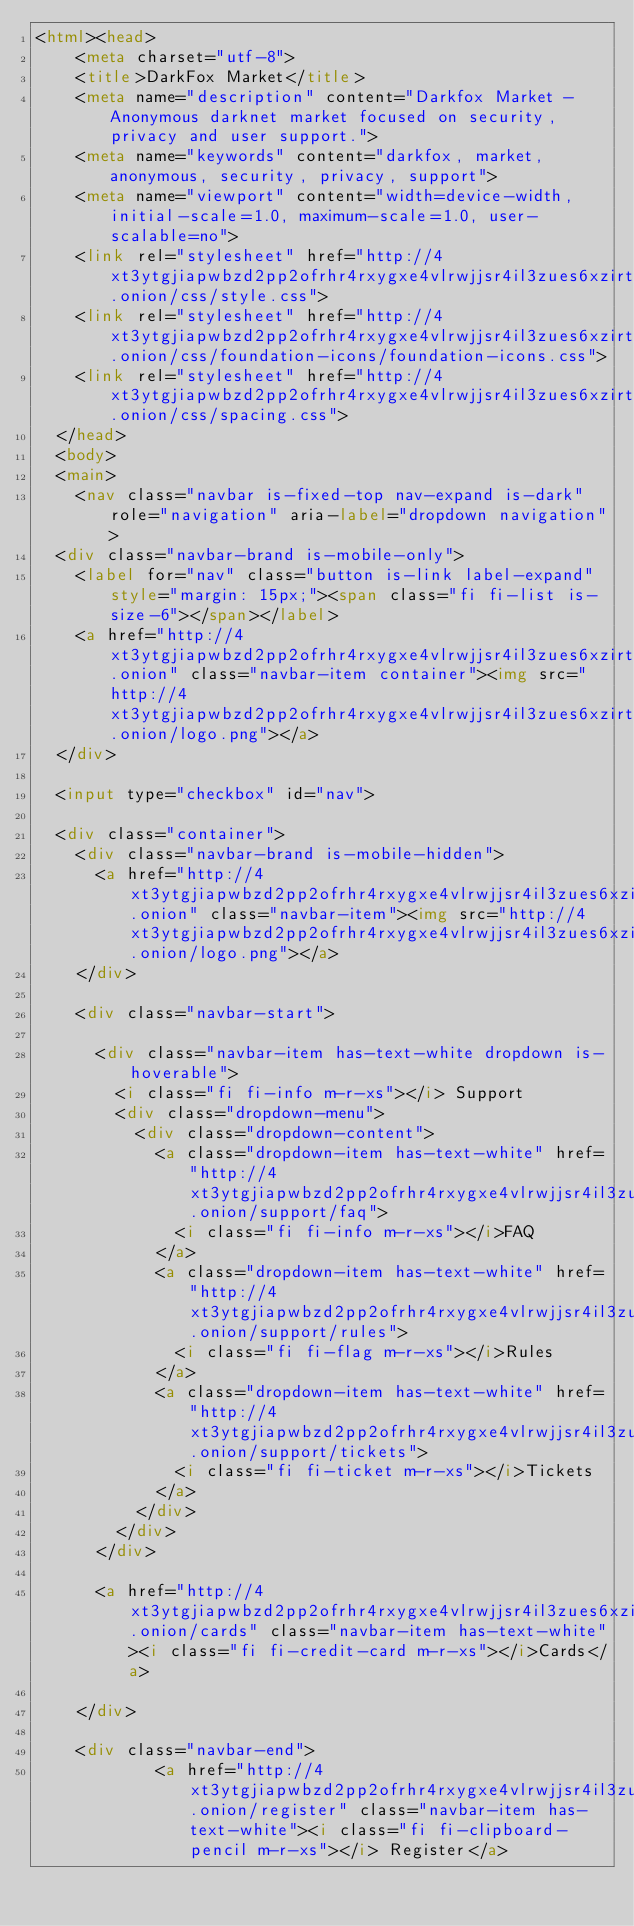<code> <loc_0><loc_0><loc_500><loc_500><_HTML_><html><head>
    <meta charset="utf-8">
    <title>DarkFox Market</title>
    <meta name="description" content="Darkfox Market - Anonymous darknet market focused on security, privacy and user support.">
    <meta name="keywords" content="darkfox, market, anonymous, security, privacy, support">
    <meta name="viewport" content="width=device-width, initial-scale=1.0, maximum-scale=1.0, user-scalable=no">
    <link rel="stylesheet" href="http://4xt3ytgjiapwbzd2pp2ofrhr4rxygxe4vlrwjjsr4il3zues6xzirtad.onion/css/style.css">
    <link rel="stylesheet" href="http://4xt3ytgjiapwbzd2pp2ofrhr4rxygxe4vlrwjjsr4il3zues6xzirtad.onion/css/foundation-icons/foundation-icons.css">
    <link rel="stylesheet" href="http://4xt3ytgjiapwbzd2pp2ofrhr4rxygxe4vlrwjjsr4il3zues6xzirtad.onion/css/spacing.css">
  </head>
  <body>
  <main>
    <nav class="navbar is-fixed-top nav-expand is-dark" role="navigation" aria-label="dropdown navigation">
  <div class="navbar-brand is-mobile-only">
    <label for="nav" class="button is-link label-expand" style="margin: 15px;"><span class="fi fi-list is-size-6"></span></label>
    <a href="http://4xt3ytgjiapwbzd2pp2ofrhr4rxygxe4vlrwjjsr4il3zues6xzirtad.onion" class="navbar-item container"><img src="http://4xt3ytgjiapwbzd2pp2ofrhr4rxygxe4vlrwjjsr4il3zues6xzirtad.onion/logo.png"></a>
  </div>
  
  <input type="checkbox" id="nav">
  
  <div class="container">
    <div class="navbar-brand is-mobile-hidden">
      <a href="http://4xt3ytgjiapwbzd2pp2ofrhr4rxygxe4vlrwjjsr4il3zues6xzirtad.onion" class="navbar-item"><img src="http://4xt3ytgjiapwbzd2pp2ofrhr4rxygxe4vlrwjjsr4il3zues6xzirtad.onion/logo.png"></a>
    </div>

    <div class="navbar-start">
      
      <div class="navbar-item has-text-white dropdown is-hoverable">
        <i class="fi fi-info m-r-xs"></i> Support
        <div class="dropdown-menu">
          <div class="dropdown-content">
            <a class="dropdown-item has-text-white" href="http://4xt3ytgjiapwbzd2pp2ofrhr4rxygxe4vlrwjjsr4il3zues6xzirtad.onion/support/faq">
              <i class="fi fi-info m-r-xs"></i>FAQ
            </a>
            <a class="dropdown-item has-text-white" href="http://4xt3ytgjiapwbzd2pp2ofrhr4rxygxe4vlrwjjsr4il3zues6xzirtad.onion/support/rules">
              <i class="fi fi-flag m-r-xs"></i>Rules
            </a>
            <a class="dropdown-item has-text-white" href="http://4xt3ytgjiapwbzd2pp2ofrhr4rxygxe4vlrwjjsr4il3zues6xzirtad.onion/support/tickets">
              <i class="fi fi-ticket m-r-xs"></i>Tickets
            </a>
          </div>
        </div>
      </div>

      <a href="http://4xt3ytgjiapwbzd2pp2ofrhr4rxygxe4vlrwjjsr4il3zues6xzirtad.onion/cards" class="navbar-item has-text-white"><i class="fi fi-credit-card m-r-xs"></i>Cards</a>

    </div>

    <div class="navbar-end">
            <a href="http://4xt3ytgjiapwbzd2pp2ofrhr4rxygxe4vlrwjjsr4il3zues6xzirtad.onion/register" class="navbar-item has-text-white"><i class="fi fi-clipboard-pencil m-r-xs"></i> Register</a></code> 